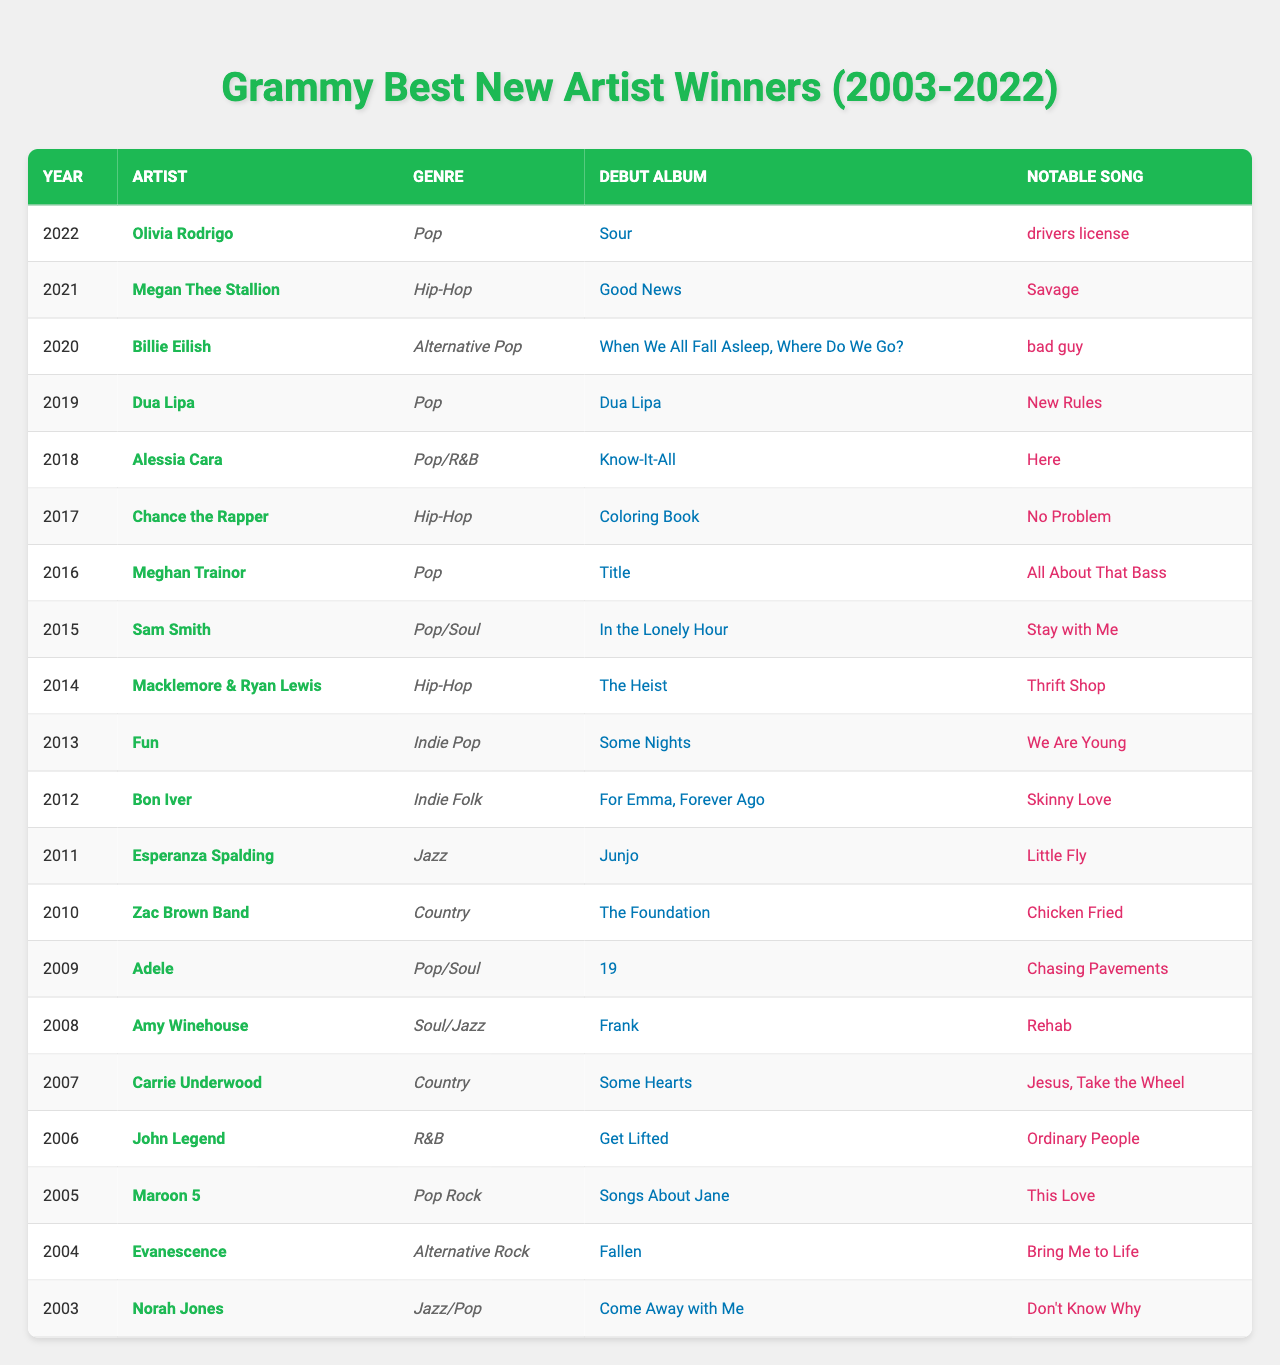What year did Billie Eilish win the Best New Artist award? Referring to the table, Billie Eilish is listed as the winner for the year 2020.
Answer: 2020 Which genre did Olivia Rodrigo represent when she won Best New Artist? The table indicates that Olivia Rodrigo is associated with the Pop genre.
Answer: Pop How many artists in the table represent the Hip-Hop genre? By counting the entries in the table, we find that there are four artists: Megan Thee Stallion, Chance the Rapper, and Macklemore & Ryan Lewis who represent Hip-Hop.
Answer: 4 Who won the award in 2014 and what was their notable song? The table shows that Macklemore & Ryan Lewis won the award in 2014, and their notable song is "Thrift Shop."
Answer: Macklemore & Ryan Lewis, "Thrift Shop" Which artist won in 2019 and what was their debut album? According to the table, Dua Lipa won in 2019, and her debut album is "Dua Lipa."
Answer: Dua Lipa, "Dua Lipa" Is it true that Maroon 5 won the Best New Artist award? Looking at the table, Maroon 5 is listed as the winner in 2005, confirming that it is true.
Answer: Yes What is the notable song of the Best New Artist winner in 2011? The table indicates that Esperanza Spalding won in 2011, and her notable song is "Little Fly."
Answer: "Little Fly" How many artists listed have a notable song released in the last five years? Referring to the 2018 to 2022 entries, Olivia Rodrigo, Megan Thee Stallion, and Billie Eilish have notable songs that fit this criterion, totaling three artists.
Answer: 3 What is the average year of the winners in the table? Summing the years from 2003 to 2022 gives a total of 400, and there are 20 winners. Dividing 400 by 20 yields an average year of 2012.
Answer: 2012 List the artist who won in the year before Chance the Rapper and their genre. The table shows that Meghan Trainor won in 2016, and her genre is Pop.
Answer: Meghan Trainor, Pop Which artist from the table had a debut album named "For Emma, Forever Ago"? The table indicates that Bon Iver had a debut album titled "For Emma, Forever Ago."
Answer: Bon Iver 